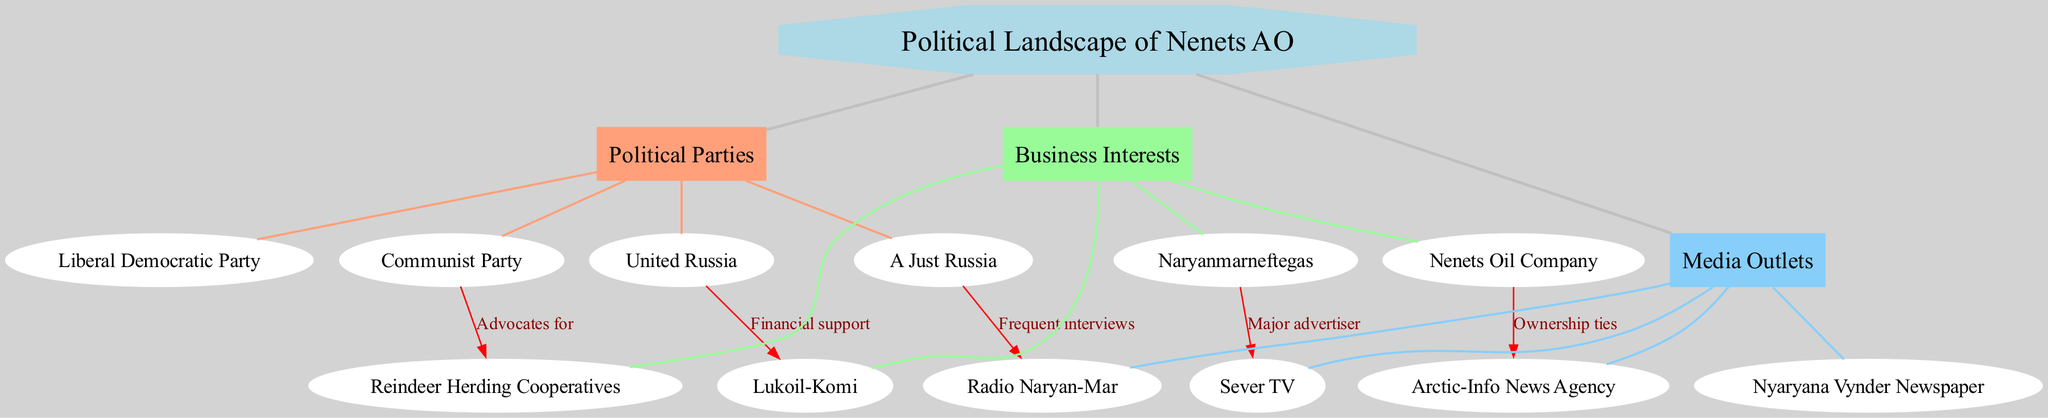What is the central node of the diagram? The central node is explicitly labeled as "Political Landscape of Nenets AO." This is the starting point from which the main branches extend.
Answer: Political Landscape of Nenets AO How many political parties are shown in the diagram? The diagram lists four subnodes under the "Political Parties" branch: United Russia, Communist Party, Liberal Democratic Party, and A Just Russia. Counting these gives a total of four political parties.
Answer: 4 Which business interest has ownership ties with Arctic-Info News Agency? The diagram indicates a connection that specifies "Nenets Oil Company" as having ownership ties with the "Arctic-Info News Agency." This relationship is directly labeled in the connections section.
Answer: Nenets Oil Company What type of support does United Russia receive from Lukoil-Komi? The diagram categorizes the relationship between United Russia and Lukoil-Komi as "Financial support." This label clearly indicates the nature of their connection.
Answer: Financial support Which media outlet is listed as a major advertiser for Naryanmarneftegas? According to the diagram, "Sever TV" is specified as a "Major advertiser" for "Naryanmarneftegas." This connection denotes a financial relationship in advertising.
Answer: Sever TV How many subnodes are there under the Business Interests branch? The "Business Interests" branch has four subnodes: Lukoil-Komi, Naryanmarneftegas, Nenets Oil Company, and Reindeer Herding Cooperatives. This is counted directly from the branch.
Answer: 4 Which political party advocates for Reindeer Herding Cooperatives? The "Communist Party" is explicitly shown to be advocating for the "Reindeer Herding Cooperatives" in the diagram, denoting a support relationship.
Answer: Communist Party How many connections are there between political parties and business interests? The diagram shows a total of five connections between political parties and business interests, linking each political party to its respective business interest.
Answer: 5 Which political party has frequent interviews with Radio Naryan-Mar? The diagram illustrates that "A Just Russia" is the political party that maintains a relationship of "Frequent interviews" with "Radio Naryan-Mar."
Answer: A Just Russia 